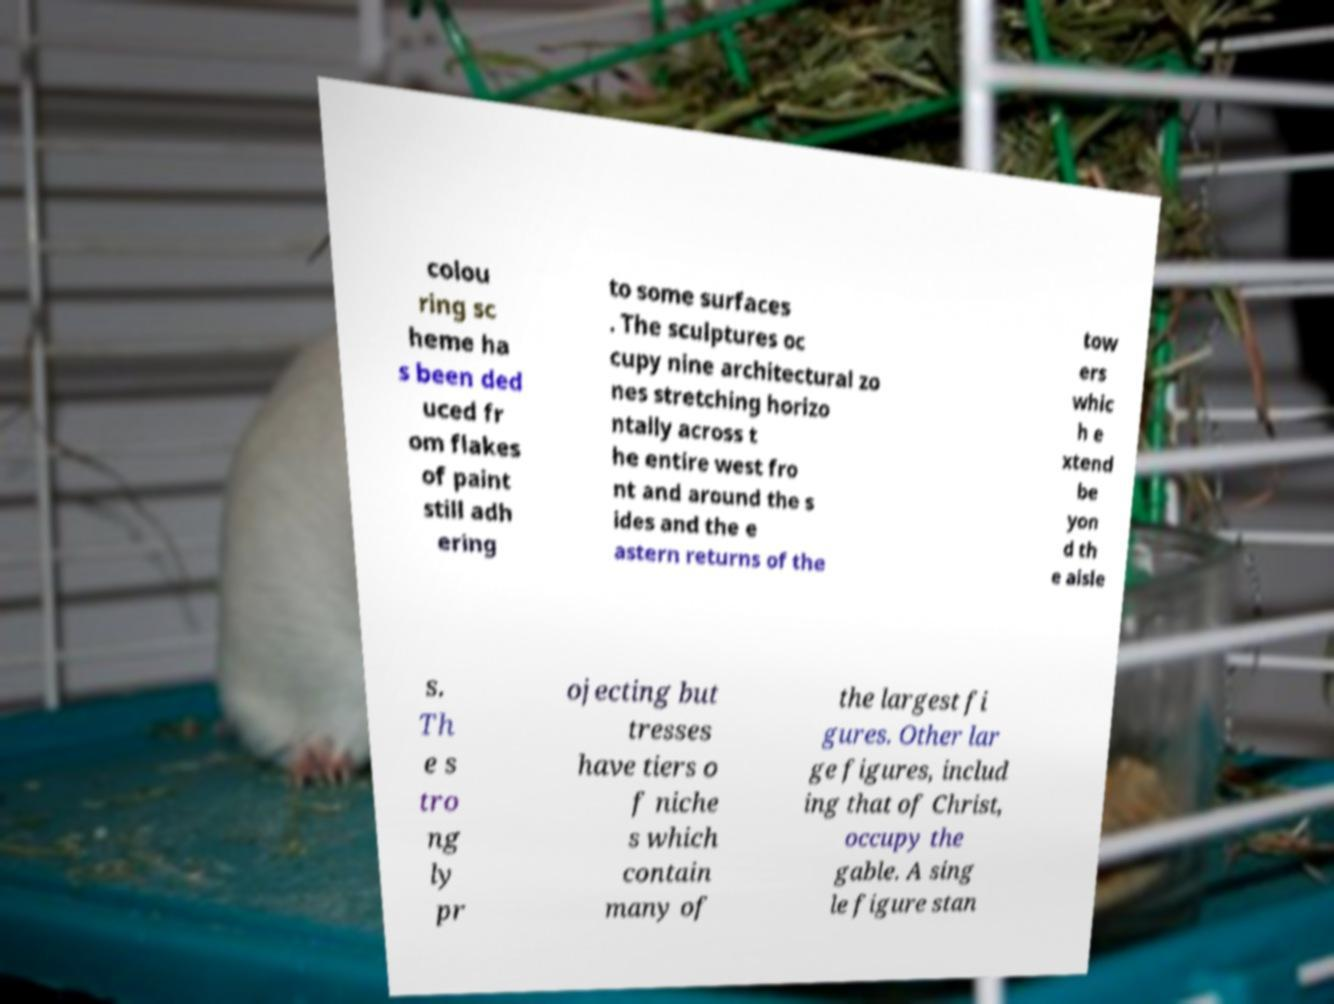For documentation purposes, I need the text within this image transcribed. Could you provide that? colou ring sc heme ha s been ded uced fr om flakes of paint still adh ering to some surfaces . The sculptures oc cupy nine architectural zo nes stretching horizo ntally across t he entire west fro nt and around the s ides and the e astern returns of the tow ers whic h e xtend be yon d th e aisle s. Th e s tro ng ly pr ojecting but tresses have tiers o f niche s which contain many of the largest fi gures. Other lar ge figures, includ ing that of Christ, occupy the gable. A sing le figure stan 